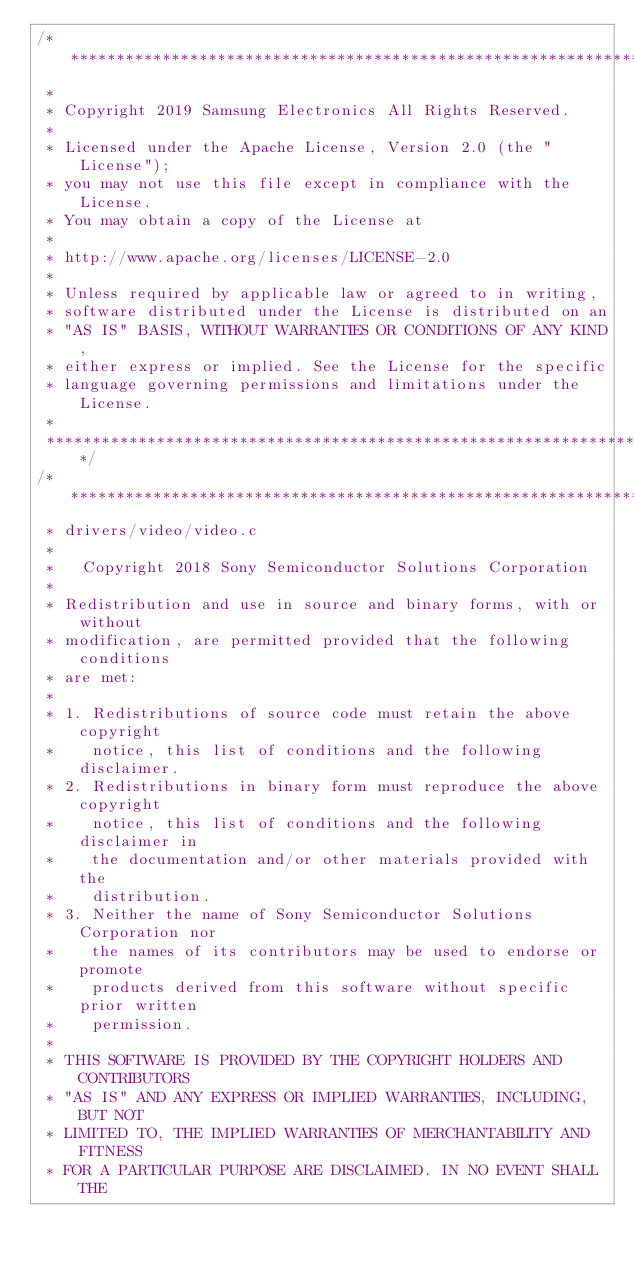Convert code to text. <code><loc_0><loc_0><loc_500><loc_500><_C_>/****************************************************************************
 *
 * Copyright 2019 Samsung Electronics All Rights Reserved.
 *
 * Licensed under the Apache License, Version 2.0 (the "License");
 * you may not use this file except in compliance with the License.
 * You may obtain a copy of the License at
 *
 * http://www.apache.org/licenses/LICENSE-2.0
 *
 * Unless required by applicable law or agreed to in writing,
 * software distributed under the License is distributed on an
 * "AS IS" BASIS, WITHOUT WARRANTIES OR CONDITIONS OF ANY KIND,
 * either express or implied. See the License for the specific
 * language governing permissions and limitations under the License.
 *
 ****************************************************************************/
/****************************************************************************
 * drivers/video/video.c
 *
 *   Copyright 2018 Sony Semiconductor Solutions Corporation
 *
 * Redistribution and use in source and binary forms, with or without
 * modification, are permitted provided that the following conditions
 * are met:
 *
 * 1. Redistributions of source code must retain the above copyright
 *    notice, this list of conditions and the following disclaimer.
 * 2. Redistributions in binary form must reproduce the above copyright
 *    notice, this list of conditions and the following disclaimer in
 *    the documentation and/or other materials provided with the
 *    distribution.
 * 3. Neither the name of Sony Semiconductor Solutions Corporation nor
 *    the names of its contributors may be used to endorse or promote
 *    products derived from this software without specific prior written
 *    permission.
 *
 * THIS SOFTWARE IS PROVIDED BY THE COPYRIGHT HOLDERS AND CONTRIBUTORS
 * "AS IS" AND ANY EXPRESS OR IMPLIED WARRANTIES, INCLUDING, BUT NOT
 * LIMITED TO, THE IMPLIED WARRANTIES OF MERCHANTABILITY AND FITNESS
 * FOR A PARTICULAR PURPOSE ARE DISCLAIMED. IN NO EVENT SHALL THE</code> 